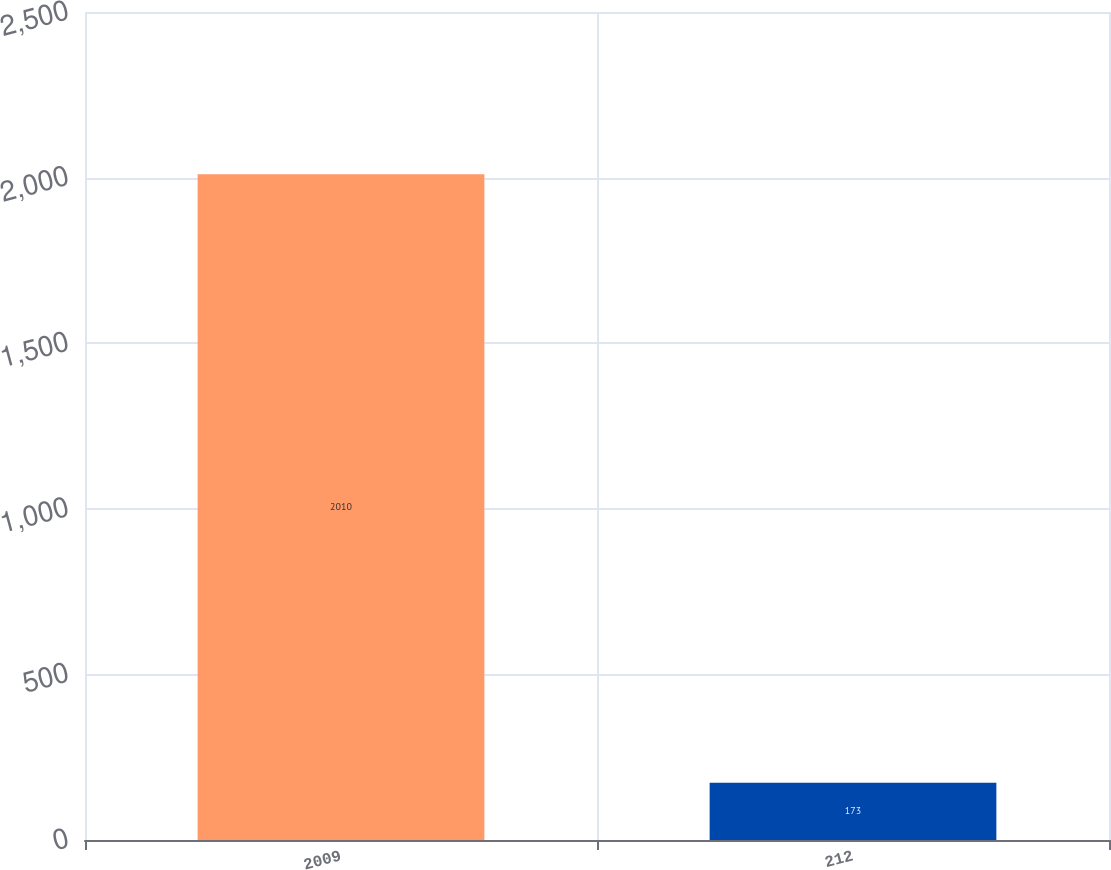<chart> <loc_0><loc_0><loc_500><loc_500><bar_chart><fcel>2009<fcel>212<nl><fcel>2010<fcel>173<nl></chart> 